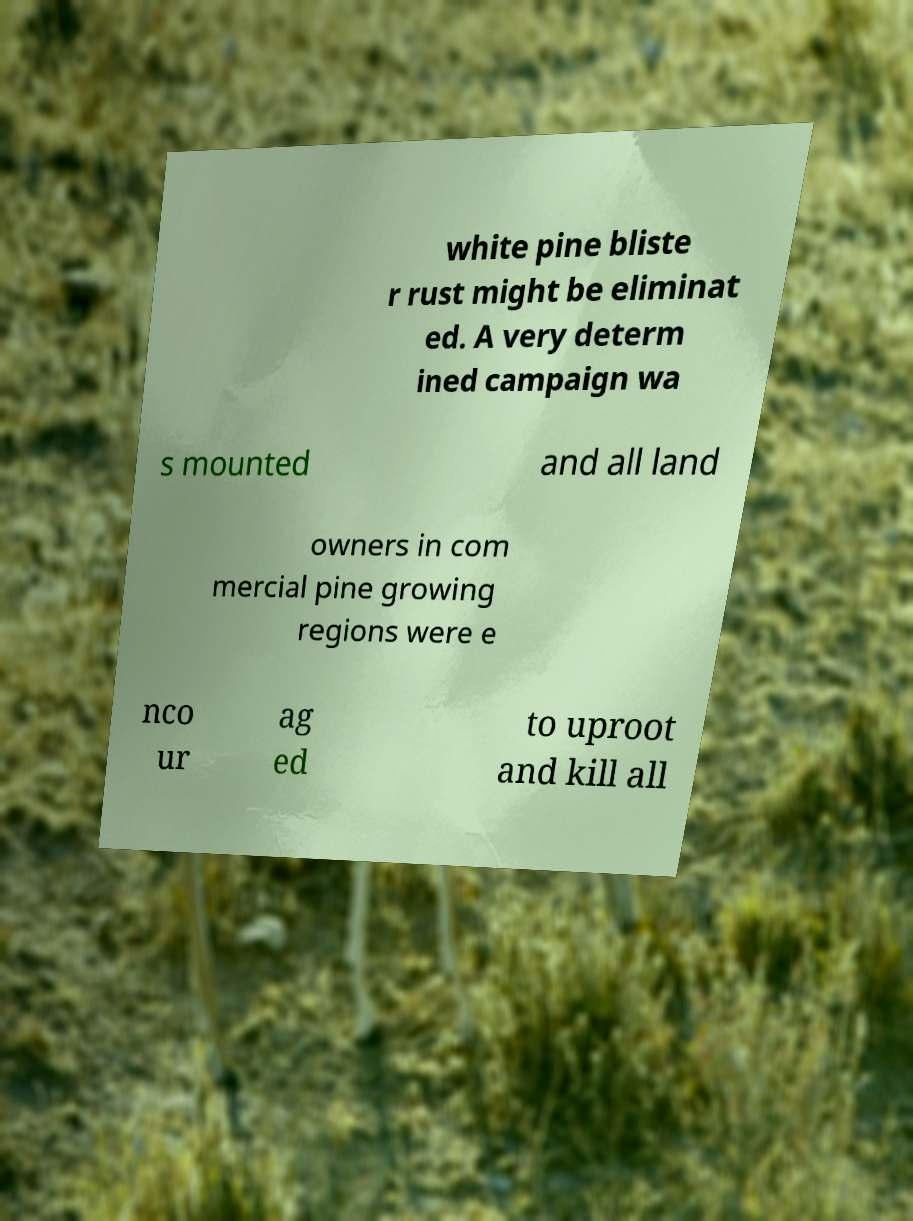Could you extract and type out the text from this image? white pine bliste r rust might be eliminat ed. A very determ ined campaign wa s mounted and all land owners in com mercial pine growing regions were e nco ur ag ed to uproot and kill all 